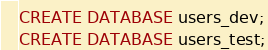Convert code to text. <code><loc_0><loc_0><loc_500><loc_500><_SQL_>CREATE DATABASE users_dev;
CREATE DATABASE users_test;
</code> 